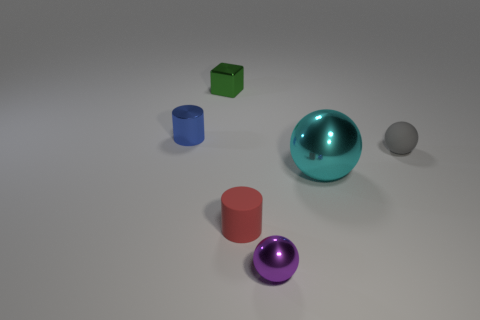Are there any small cyan matte objects of the same shape as the tiny blue metallic thing?
Provide a short and direct response. No. There is a small matte thing in front of the tiny matte sphere; what is its shape?
Offer a very short reply. Cylinder. There is a cylinder that is in front of the object on the left side of the small green cube; what number of small things are on the left side of it?
Keep it short and to the point. 2. How many other objects are there of the same shape as the gray object?
Provide a succinct answer. 2. What number of other objects are there of the same material as the green object?
Provide a succinct answer. 3. The sphere on the right side of the big ball in front of the small ball behind the red rubber thing is made of what material?
Provide a succinct answer. Rubber. Does the blue thing have the same material as the large cyan ball?
Your response must be concise. Yes. How many cubes are either purple metallic objects or tiny blue metallic things?
Your response must be concise. 0. There is a small cylinder behind the red cylinder; what color is it?
Make the answer very short. Blue. How many metal objects are either red cylinders or small gray balls?
Keep it short and to the point. 0. 